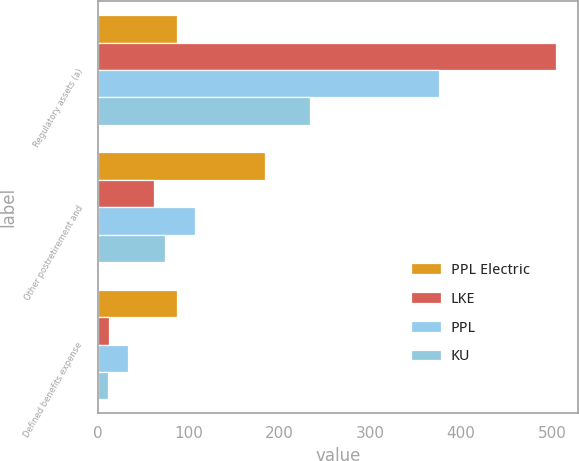Convert chart to OTSL. <chart><loc_0><loc_0><loc_500><loc_500><stacked_bar_chart><ecel><fcel>Regulatory assets (a)<fcel>Other postretirement and<fcel>Defined benefits expense<nl><fcel>PPL Electric<fcel>87<fcel>184<fcel>87<nl><fcel>LKE<fcel>504<fcel>62<fcel>12<nl><fcel>PPL<fcel>376<fcel>107<fcel>33<nl><fcel>KU<fcel>234<fcel>74<fcel>11<nl></chart> 